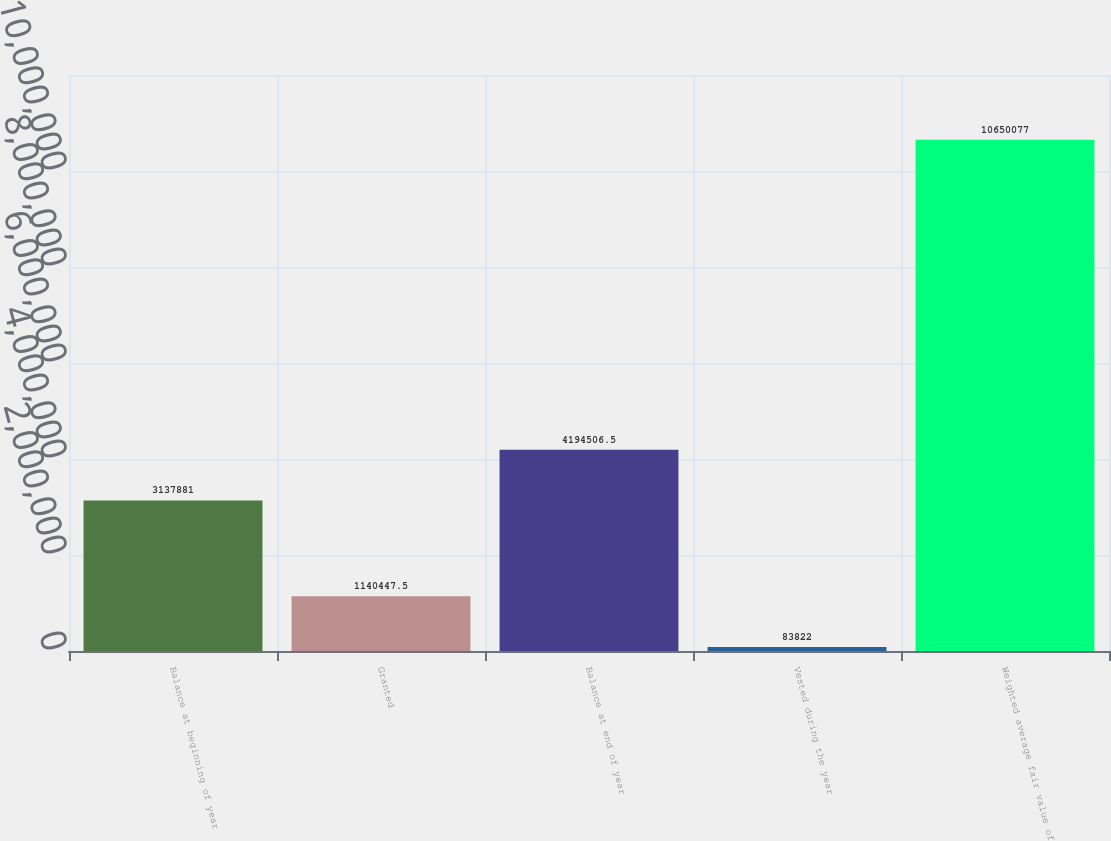Convert chart. <chart><loc_0><loc_0><loc_500><loc_500><bar_chart><fcel>Balance at beginning of year<fcel>Granted<fcel>Balance at end of year<fcel>Vested during the year<fcel>Weighted average fair value of<nl><fcel>3.13788e+06<fcel>1.14045e+06<fcel>4.19451e+06<fcel>83822<fcel>1.06501e+07<nl></chart> 